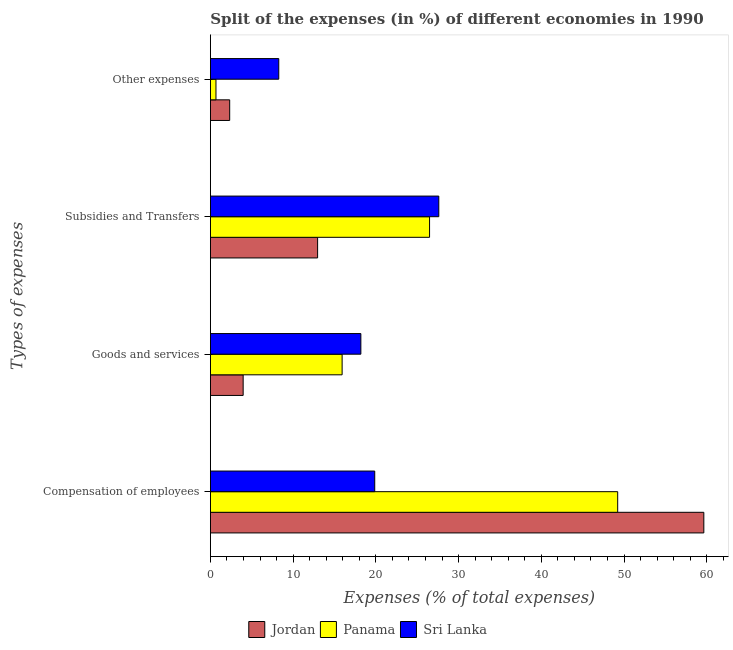Are the number of bars on each tick of the Y-axis equal?
Your response must be concise. Yes. How many bars are there on the 1st tick from the top?
Keep it short and to the point. 3. What is the label of the 3rd group of bars from the top?
Provide a short and direct response. Goods and services. What is the percentage of amount spent on subsidies in Sri Lanka?
Offer a terse response. 27.61. Across all countries, what is the maximum percentage of amount spent on other expenses?
Your answer should be very brief. 8.26. Across all countries, what is the minimum percentage of amount spent on goods and services?
Ensure brevity in your answer.  3.96. In which country was the percentage of amount spent on compensation of employees maximum?
Ensure brevity in your answer.  Jordan. In which country was the percentage of amount spent on compensation of employees minimum?
Provide a short and direct response. Sri Lanka. What is the total percentage of amount spent on compensation of employees in the graph?
Give a very brief answer. 128.74. What is the difference between the percentage of amount spent on other expenses in Panama and that in Sri Lanka?
Your answer should be very brief. -7.59. What is the difference between the percentage of amount spent on compensation of employees in Jordan and the percentage of amount spent on other expenses in Sri Lanka?
Provide a succinct answer. 51.38. What is the average percentage of amount spent on compensation of employees per country?
Your answer should be compact. 42.91. What is the difference between the percentage of amount spent on other expenses and percentage of amount spent on subsidies in Sri Lanka?
Offer a very short reply. -19.35. What is the ratio of the percentage of amount spent on other expenses in Panama to that in Sri Lanka?
Give a very brief answer. 0.08. Is the percentage of amount spent on other expenses in Jordan less than that in Sri Lanka?
Make the answer very short. Yes. What is the difference between the highest and the second highest percentage of amount spent on other expenses?
Offer a very short reply. 5.93. What is the difference between the highest and the lowest percentage of amount spent on goods and services?
Provide a succinct answer. 14.23. In how many countries, is the percentage of amount spent on compensation of employees greater than the average percentage of amount spent on compensation of employees taken over all countries?
Offer a terse response. 2. Is it the case that in every country, the sum of the percentage of amount spent on goods and services and percentage of amount spent on subsidies is greater than the sum of percentage of amount spent on compensation of employees and percentage of amount spent on other expenses?
Give a very brief answer. No. What does the 3rd bar from the top in Compensation of employees represents?
Offer a very short reply. Jordan. What does the 3rd bar from the bottom in Other expenses represents?
Provide a short and direct response. Sri Lanka. How many bars are there?
Provide a short and direct response. 12. How many countries are there in the graph?
Keep it short and to the point. 3. Are the values on the major ticks of X-axis written in scientific E-notation?
Ensure brevity in your answer.  No. Where does the legend appear in the graph?
Provide a succinct answer. Bottom center. How many legend labels are there?
Your response must be concise. 3. What is the title of the graph?
Offer a very short reply. Split of the expenses (in %) of different economies in 1990. Does "Turks and Caicos Islands" appear as one of the legend labels in the graph?
Your answer should be very brief. No. What is the label or title of the X-axis?
Give a very brief answer. Expenses (% of total expenses). What is the label or title of the Y-axis?
Make the answer very short. Types of expenses. What is the Expenses (% of total expenses) in Jordan in Compensation of employees?
Ensure brevity in your answer.  59.64. What is the Expenses (% of total expenses) of Panama in Compensation of employees?
Keep it short and to the point. 49.23. What is the Expenses (% of total expenses) in Sri Lanka in Compensation of employees?
Provide a succinct answer. 19.87. What is the Expenses (% of total expenses) of Jordan in Goods and services?
Keep it short and to the point. 3.96. What is the Expenses (% of total expenses) of Panama in Goods and services?
Your answer should be compact. 15.92. What is the Expenses (% of total expenses) in Sri Lanka in Goods and services?
Provide a succinct answer. 18.19. What is the Expenses (% of total expenses) of Jordan in Subsidies and Transfers?
Make the answer very short. 12.96. What is the Expenses (% of total expenses) of Panama in Subsidies and Transfers?
Ensure brevity in your answer.  26.49. What is the Expenses (% of total expenses) of Sri Lanka in Subsidies and Transfers?
Give a very brief answer. 27.61. What is the Expenses (% of total expenses) of Jordan in Other expenses?
Provide a succinct answer. 2.33. What is the Expenses (% of total expenses) of Panama in Other expenses?
Offer a terse response. 0.68. What is the Expenses (% of total expenses) in Sri Lanka in Other expenses?
Your answer should be very brief. 8.26. Across all Types of expenses, what is the maximum Expenses (% of total expenses) of Jordan?
Provide a short and direct response. 59.64. Across all Types of expenses, what is the maximum Expenses (% of total expenses) in Panama?
Offer a terse response. 49.23. Across all Types of expenses, what is the maximum Expenses (% of total expenses) in Sri Lanka?
Provide a short and direct response. 27.61. Across all Types of expenses, what is the minimum Expenses (% of total expenses) in Jordan?
Offer a terse response. 2.33. Across all Types of expenses, what is the minimum Expenses (% of total expenses) of Panama?
Offer a terse response. 0.68. Across all Types of expenses, what is the minimum Expenses (% of total expenses) in Sri Lanka?
Provide a short and direct response. 8.26. What is the total Expenses (% of total expenses) in Jordan in the graph?
Your response must be concise. 78.9. What is the total Expenses (% of total expenses) in Panama in the graph?
Provide a short and direct response. 92.32. What is the total Expenses (% of total expenses) of Sri Lanka in the graph?
Your response must be concise. 73.93. What is the difference between the Expenses (% of total expenses) in Jordan in Compensation of employees and that in Goods and services?
Offer a terse response. 55.68. What is the difference between the Expenses (% of total expenses) of Panama in Compensation of employees and that in Goods and services?
Provide a succinct answer. 33.31. What is the difference between the Expenses (% of total expenses) in Sri Lanka in Compensation of employees and that in Goods and services?
Make the answer very short. 1.68. What is the difference between the Expenses (% of total expenses) of Jordan in Compensation of employees and that in Subsidies and Transfers?
Your response must be concise. 46.68. What is the difference between the Expenses (% of total expenses) in Panama in Compensation of employees and that in Subsidies and Transfers?
Your answer should be compact. 22.74. What is the difference between the Expenses (% of total expenses) of Sri Lanka in Compensation of employees and that in Subsidies and Transfers?
Make the answer very short. -7.75. What is the difference between the Expenses (% of total expenses) in Jordan in Compensation of employees and that in Other expenses?
Ensure brevity in your answer.  57.31. What is the difference between the Expenses (% of total expenses) in Panama in Compensation of employees and that in Other expenses?
Your answer should be compact. 48.56. What is the difference between the Expenses (% of total expenses) in Sri Lanka in Compensation of employees and that in Other expenses?
Make the answer very short. 11.6. What is the difference between the Expenses (% of total expenses) of Jordan in Goods and services and that in Subsidies and Transfers?
Your response must be concise. -9. What is the difference between the Expenses (% of total expenses) in Panama in Goods and services and that in Subsidies and Transfers?
Your answer should be very brief. -10.57. What is the difference between the Expenses (% of total expenses) of Sri Lanka in Goods and services and that in Subsidies and Transfers?
Make the answer very short. -9.42. What is the difference between the Expenses (% of total expenses) in Jordan in Goods and services and that in Other expenses?
Offer a terse response. 1.63. What is the difference between the Expenses (% of total expenses) in Panama in Goods and services and that in Other expenses?
Provide a short and direct response. 15.25. What is the difference between the Expenses (% of total expenses) of Sri Lanka in Goods and services and that in Other expenses?
Offer a terse response. 9.92. What is the difference between the Expenses (% of total expenses) of Jordan in Subsidies and Transfers and that in Other expenses?
Your answer should be compact. 10.63. What is the difference between the Expenses (% of total expenses) in Panama in Subsidies and Transfers and that in Other expenses?
Provide a short and direct response. 25.82. What is the difference between the Expenses (% of total expenses) in Sri Lanka in Subsidies and Transfers and that in Other expenses?
Provide a short and direct response. 19.35. What is the difference between the Expenses (% of total expenses) in Jordan in Compensation of employees and the Expenses (% of total expenses) in Panama in Goods and services?
Ensure brevity in your answer.  43.72. What is the difference between the Expenses (% of total expenses) of Jordan in Compensation of employees and the Expenses (% of total expenses) of Sri Lanka in Goods and services?
Offer a terse response. 41.46. What is the difference between the Expenses (% of total expenses) in Panama in Compensation of employees and the Expenses (% of total expenses) in Sri Lanka in Goods and services?
Offer a terse response. 31.04. What is the difference between the Expenses (% of total expenses) of Jordan in Compensation of employees and the Expenses (% of total expenses) of Panama in Subsidies and Transfers?
Provide a succinct answer. 33.15. What is the difference between the Expenses (% of total expenses) of Jordan in Compensation of employees and the Expenses (% of total expenses) of Sri Lanka in Subsidies and Transfers?
Make the answer very short. 32.03. What is the difference between the Expenses (% of total expenses) of Panama in Compensation of employees and the Expenses (% of total expenses) of Sri Lanka in Subsidies and Transfers?
Your answer should be very brief. 21.62. What is the difference between the Expenses (% of total expenses) in Jordan in Compensation of employees and the Expenses (% of total expenses) in Panama in Other expenses?
Give a very brief answer. 58.97. What is the difference between the Expenses (% of total expenses) of Jordan in Compensation of employees and the Expenses (% of total expenses) of Sri Lanka in Other expenses?
Ensure brevity in your answer.  51.38. What is the difference between the Expenses (% of total expenses) in Panama in Compensation of employees and the Expenses (% of total expenses) in Sri Lanka in Other expenses?
Offer a terse response. 40.97. What is the difference between the Expenses (% of total expenses) in Jordan in Goods and services and the Expenses (% of total expenses) in Panama in Subsidies and Transfers?
Your response must be concise. -22.53. What is the difference between the Expenses (% of total expenses) in Jordan in Goods and services and the Expenses (% of total expenses) in Sri Lanka in Subsidies and Transfers?
Ensure brevity in your answer.  -23.65. What is the difference between the Expenses (% of total expenses) of Panama in Goods and services and the Expenses (% of total expenses) of Sri Lanka in Subsidies and Transfers?
Give a very brief answer. -11.69. What is the difference between the Expenses (% of total expenses) in Jordan in Goods and services and the Expenses (% of total expenses) in Panama in Other expenses?
Make the answer very short. 3.29. What is the difference between the Expenses (% of total expenses) of Jordan in Goods and services and the Expenses (% of total expenses) of Sri Lanka in Other expenses?
Your response must be concise. -4.3. What is the difference between the Expenses (% of total expenses) in Panama in Goods and services and the Expenses (% of total expenses) in Sri Lanka in Other expenses?
Your answer should be very brief. 7.66. What is the difference between the Expenses (% of total expenses) in Jordan in Subsidies and Transfers and the Expenses (% of total expenses) in Panama in Other expenses?
Provide a succinct answer. 12.29. What is the difference between the Expenses (% of total expenses) in Jordan in Subsidies and Transfers and the Expenses (% of total expenses) in Sri Lanka in Other expenses?
Offer a terse response. 4.7. What is the difference between the Expenses (% of total expenses) of Panama in Subsidies and Transfers and the Expenses (% of total expenses) of Sri Lanka in Other expenses?
Offer a terse response. 18.23. What is the average Expenses (% of total expenses) of Jordan per Types of expenses?
Keep it short and to the point. 19.73. What is the average Expenses (% of total expenses) of Panama per Types of expenses?
Your answer should be compact. 23.08. What is the average Expenses (% of total expenses) of Sri Lanka per Types of expenses?
Offer a terse response. 18.48. What is the difference between the Expenses (% of total expenses) of Jordan and Expenses (% of total expenses) of Panama in Compensation of employees?
Your answer should be very brief. 10.41. What is the difference between the Expenses (% of total expenses) of Jordan and Expenses (% of total expenses) of Sri Lanka in Compensation of employees?
Offer a terse response. 39.78. What is the difference between the Expenses (% of total expenses) of Panama and Expenses (% of total expenses) of Sri Lanka in Compensation of employees?
Keep it short and to the point. 29.37. What is the difference between the Expenses (% of total expenses) of Jordan and Expenses (% of total expenses) of Panama in Goods and services?
Keep it short and to the point. -11.96. What is the difference between the Expenses (% of total expenses) in Jordan and Expenses (% of total expenses) in Sri Lanka in Goods and services?
Offer a terse response. -14.23. What is the difference between the Expenses (% of total expenses) in Panama and Expenses (% of total expenses) in Sri Lanka in Goods and services?
Ensure brevity in your answer.  -2.27. What is the difference between the Expenses (% of total expenses) in Jordan and Expenses (% of total expenses) in Panama in Subsidies and Transfers?
Offer a very short reply. -13.53. What is the difference between the Expenses (% of total expenses) of Jordan and Expenses (% of total expenses) of Sri Lanka in Subsidies and Transfers?
Your answer should be compact. -14.65. What is the difference between the Expenses (% of total expenses) in Panama and Expenses (% of total expenses) in Sri Lanka in Subsidies and Transfers?
Your answer should be compact. -1.12. What is the difference between the Expenses (% of total expenses) in Jordan and Expenses (% of total expenses) in Panama in Other expenses?
Give a very brief answer. 1.66. What is the difference between the Expenses (% of total expenses) in Jordan and Expenses (% of total expenses) in Sri Lanka in Other expenses?
Offer a terse response. -5.93. What is the difference between the Expenses (% of total expenses) in Panama and Expenses (% of total expenses) in Sri Lanka in Other expenses?
Provide a short and direct response. -7.59. What is the ratio of the Expenses (% of total expenses) in Jordan in Compensation of employees to that in Goods and services?
Provide a short and direct response. 15.06. What is the ratio of the Expenses (% of total expenses) of Panama in Compensation of employees to that in Goods and services?
Your answer should be compact. 3.09. What is the ratio of the Expenses (% of total expenses) in Sri Lanka in Compensation of employees to that in Goods and services?
Your answer should be compact. 1.09. What is the ratio of the Expenses (% of total expenses) in Jordan in Compensation of employees to that in Subsidies and Transfers?
Your answer should be very brief. 4.6. What is the ratio of the Expenses (% of total expenses) in Panama in Compensation of employees to that in Subsidies and Transfers?
Offer a very short reply. 1.86. What is the ratio of the Expenses (% of total expenses) of Sri Lanka in Compensation of employees to that in Subsidies and Transfers?
Your response must be concise. 0.72. What is the ratio of the Expenses (% of total expenses) of Jordan in Compensation of employees to that in Other expenses?
Give a very brief answer. 25.56. What is the ratio of the Expenses (% of total expenses) in Panama in Compensation of employees to that in Other expenses?
Give a very brief answer. 72.92. What is the ratio of the Expenses (% of total expenses) of Sri Lanka in Compensation of employees to that in Other expenses?
Offer a very short reply. 2.4. What is the ratio of the Expenses (% of total expenses) in Jordan in Goods and services to that in Subsidies and Transfers?
Offer a terse response. 0.31. What is the ratio of the Expenses (% of total expenses) of Panama in Goods and services to that in Subsidies and Transfers?
Your answer should be compact. 0.6. What is the ratio of the Expenses (% of total expenses) in Sri Lanka in Goods and services to that in Subsidies and Transfers?
Keep it short and to the point. 0.66. What is the ratio of the Expenses (% of total expenses) of Jordan in Goods and services to that in Other expenses?
Give a very brief answer. 1.7. What is the ratio of the Expenses (% of total expenses) in Panama in Goods and services to that in Other expenses?
Make the answer very short. 23.58. What is the ratio of the Expenses (% of total expenses) in Sri Lanka in Goods and services to that in Other expenses?
Provide a succinct answer. 2.2. What is the ratio of the Expenses (% of total expenses) of Jordan in Subsidies and Transfers to that in Other expenses?
Provide a succinct answer. 5.55. What is the ratio of the Expenses (% of total expenses) of Panama in Subsidies and Transfers to that in Other expenses?
Your answer should be very brief. 39.24. What is the ratio of the Expenses (% of total expenses) in Sri Lanka in Subsidies and Transfers to that in Other expenses?
Keep it short and to the point. 3.34. What is the difference between the highest and the second highest Expenses (% of total expenses) in Jordan?
Keep it short and to the point. 46.68. What is the difference between the highest and the second highest Expenses (% of total expenses) of Panama?
Provide a succinct answer. 22.74. What is the difference between the highest and the second highest Expenses (% of total expenses) in Sri Lanka?
Offer a very short reply. 7.75. What is the difference between the highest and the lowest Expenses (% of total expenses) in Jordan?
Your response must be concise. 57.31. What is the difference between the highest and the lowest Expenses (% of total expenses) in Panama?
Provide a succinct answer. 48.56. What is the difference between the highest and the lowest Expenses (% of total expenses) in Sri Lanka?
Make the answer very short. 19.35. 